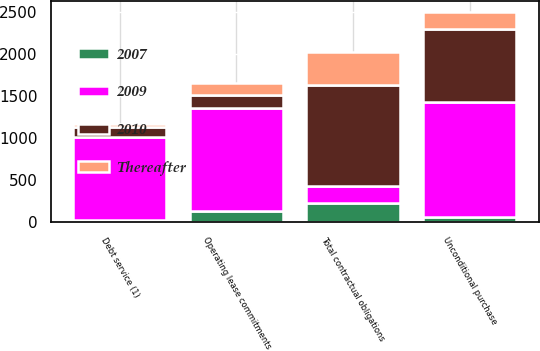Convert chart. <chart><loc_0><loc_0><loc_500><loc_500><stacked_bar_chart><ecel><fcel>Debt service (1)<fcel>Operating lease commitments<fcel>Unconditional purchase<fcel>Total contractual obligations<nl><fcel>2009<fcel>982.9<fcel>1224.3<fcel>1365.6<fcel>200.8<nl><fcel>2010<fcel>120.6<fcel>157.7<fcel>872.8<fcel>1192.3<nl><fcel>Thereafter<fcel>34.1<fcel>145.8<fcel>200.8<fcel>399.3<nl><fcel>2007<fcel>31.6<fcel>134.2<fcel>64.3<fcel>235.6<nl></chart> 